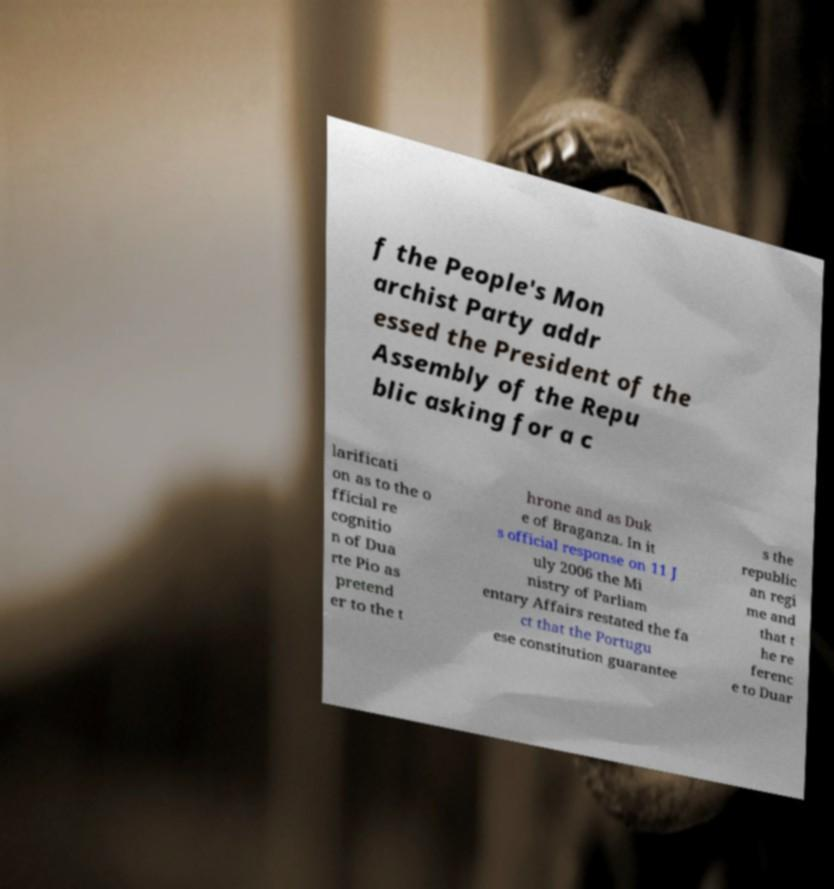There's text embedded in this image that I need extracted. Can you transcribe it verbatim? f the People's Mon archist Party addr essed the President of the Assembly of the Repu blic asking for a c larificati on as to the o fficial re cognitio n of Dua rte Pio as pretend er to the t hrone and as Duk e of Braganza. In it s official response on 11 J uly 2006 the Mi nistry of Parliam entary Affairs restated the fa ct that the Portugu ese constitution guarantee s the republic an regi me and that t he re ferenc e to Duar 